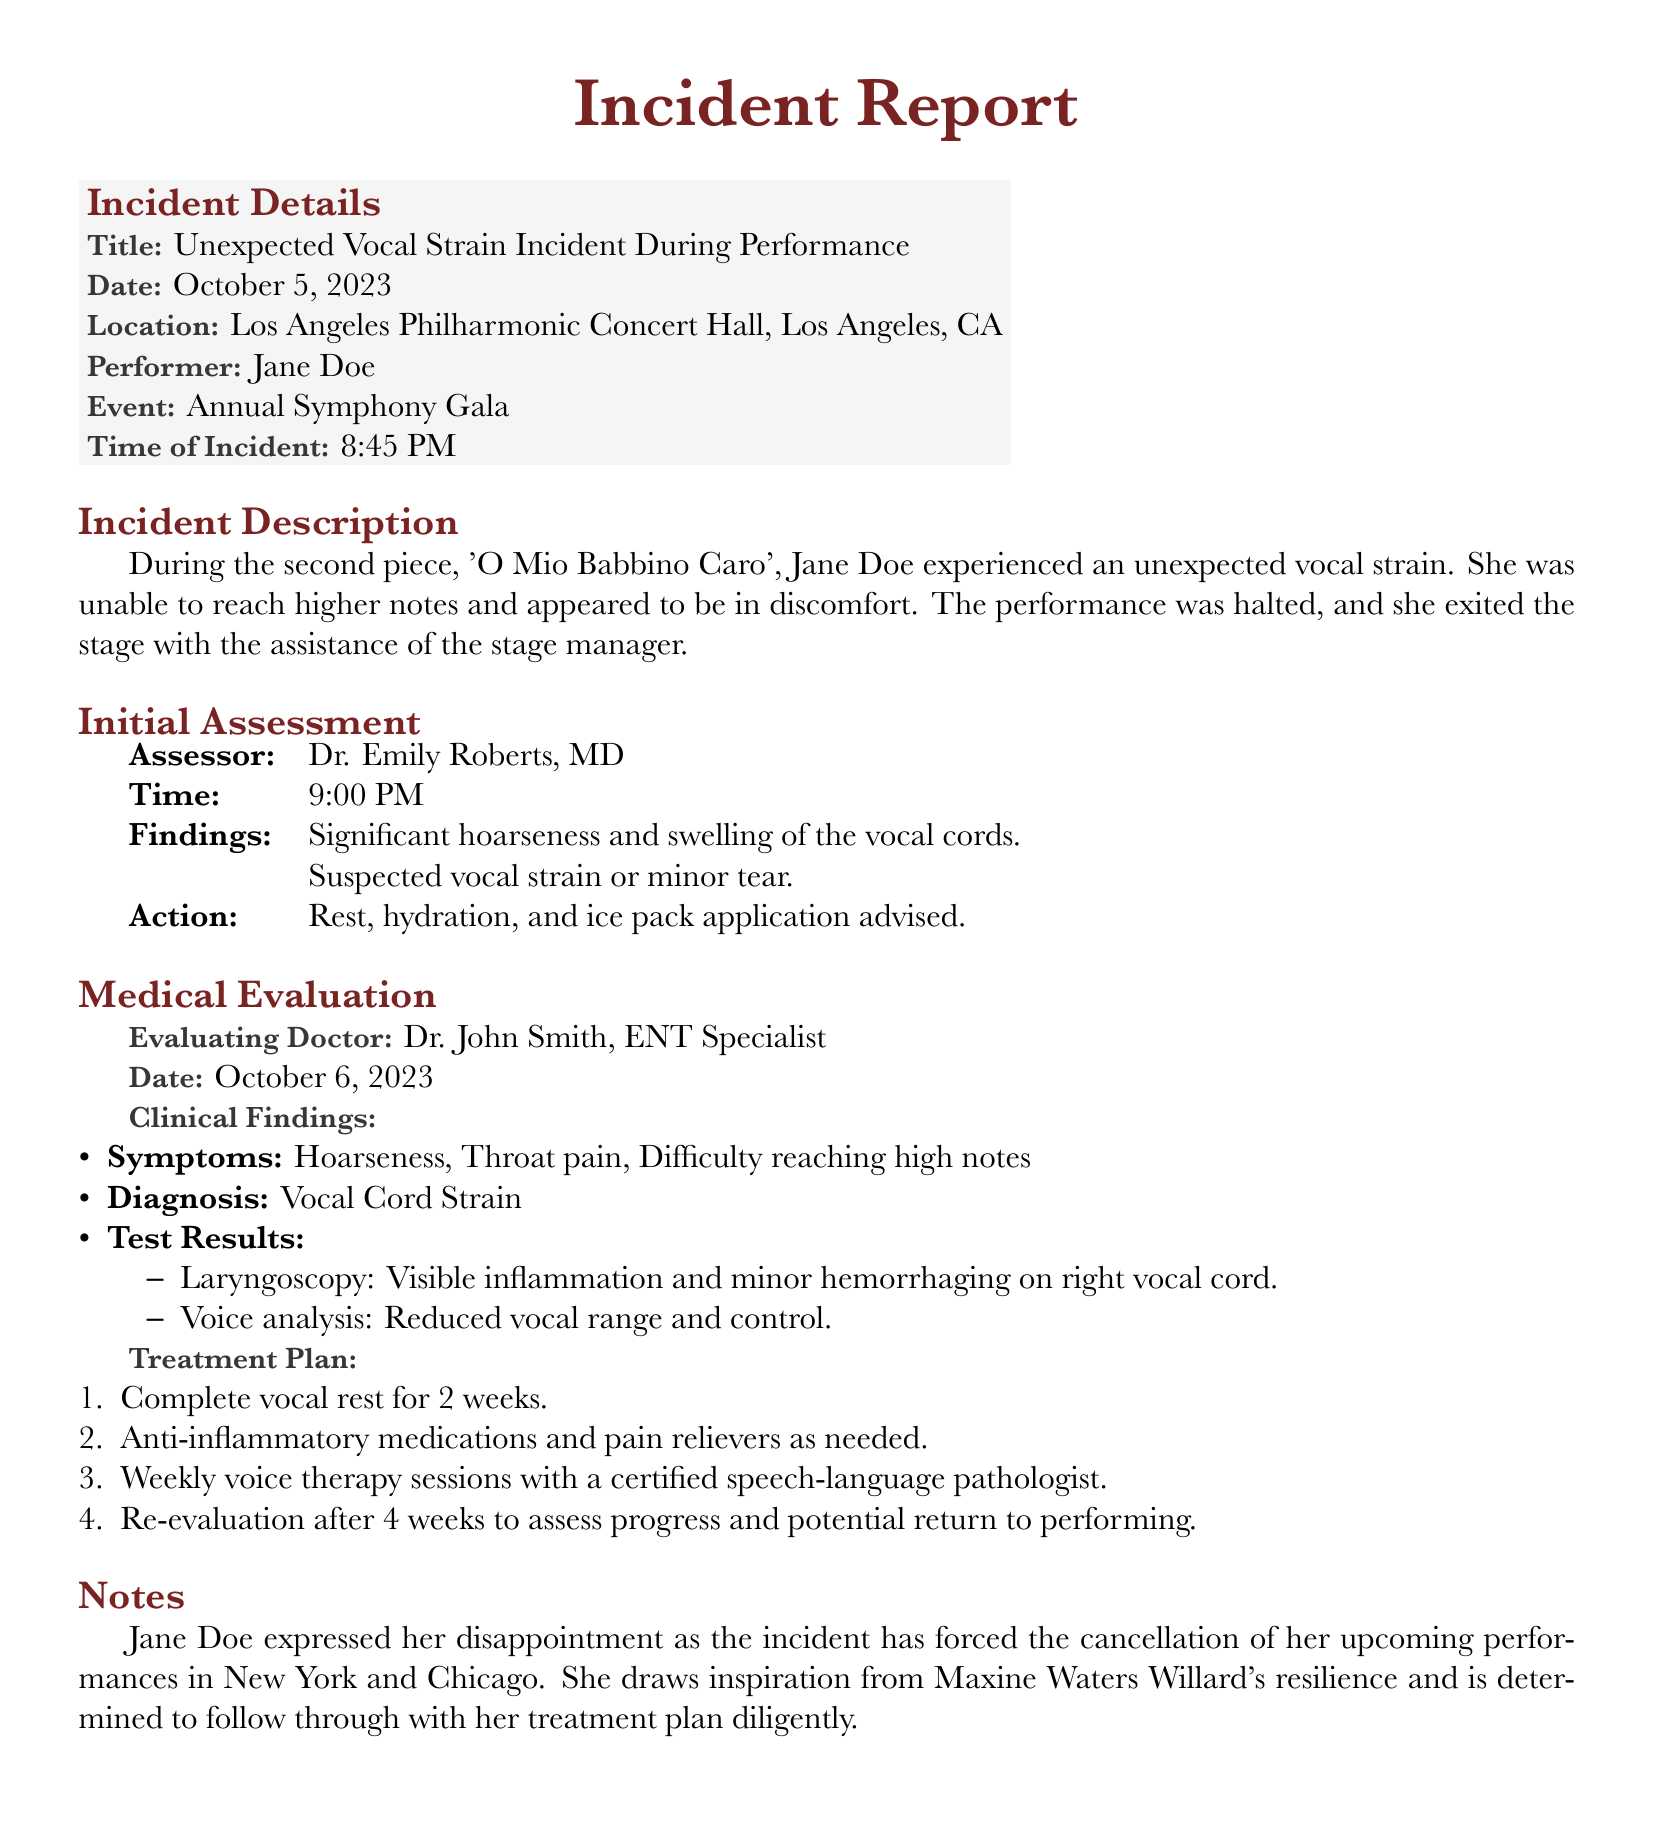What is the title of the incident? The title of the incident is stated as "Unexpected Vocal Strain Incident During Performance."
Answer: Unexpected Vocal Strain Incident During Performance Who was the performer involved in the incident? The document specifies that the performer involved in the incident is Jane Doe.
Answer: Jane Doe What time did the incident occur? The incident is recorded to have occurred at 8:45 PM.
Answer: 8:45 PM What was the initial assessment finding? The initial assessment found "Significant hoarseness and swelling of the vocal cords."
Answer: Significant hoarseness and swelling of the vocal cords How long is the recommended vocal rest? The treatment plan suggests complete vocal rest for "2 weeks."
Answer: 2 weeks Which piece was being performed when the incident occurred? The document notes that 'O Mio Babbino Caro' was the piece being performed during the incident.
Answer: O Mio Babbino Caro What did Jane Doe express regarding her upcoming performances? Jane Doe expressed her disappointment due to the incident forcing the cancellation of her upcoming performances.
Answer: Disappointment Who conducted the medical evaluation? The medical evaluation was conducted by Dr. John Smith, an ENT Specialist.
Answer: Dr. John Smith What will happen after four weeks of treatment? After four weeks, a "Re-evaluation" will occur to assess progress and potential return to performing.
Answer: Re-evaluation 